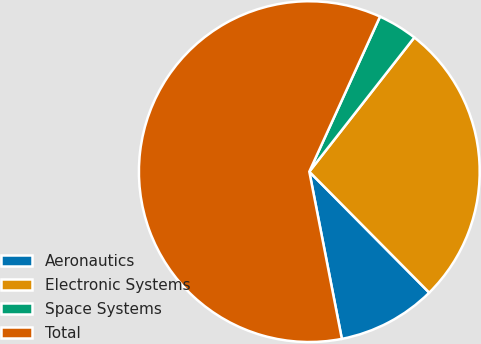Convert chart to OTSL. <chart><loc_0><loc_0><loc_500><loc_500><pie_chart><fcel>Aeronautics<fcel>Electronic Systems<fcel>Space Systems<fcel>Total<nl><fcel>9.37%<fcel>27.0%<fcel>3.76%<fcel>59.87%<nl></chart> 